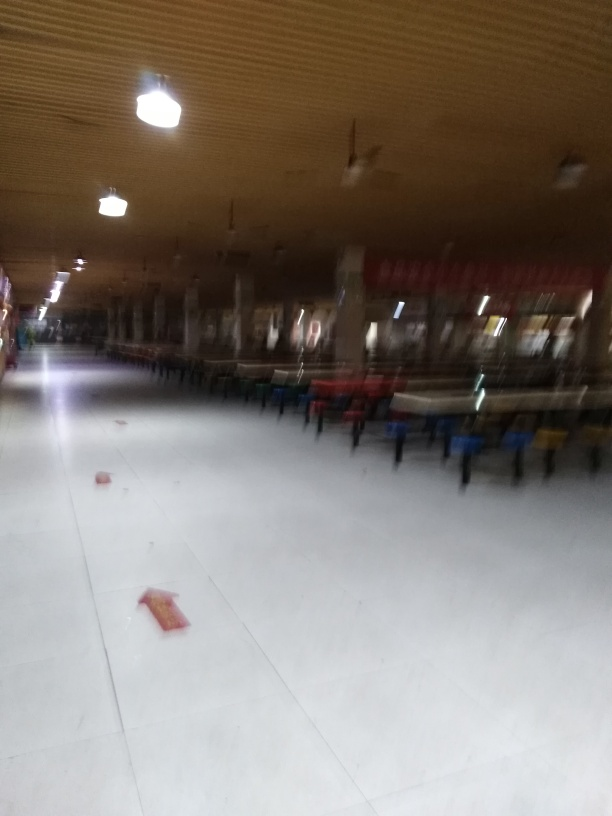Is the image properly cropped? The image is not appropriately cropped, as it appears to be taken hastily and at an angle, resulting in a skewed perspective. A well-cropped image would have balanced framing and a clear focus on the intended subject. 